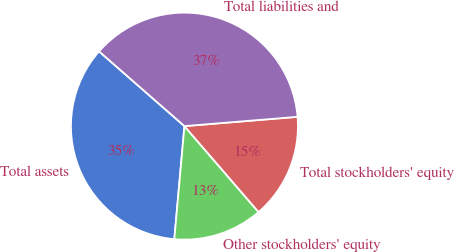<chart> <loc_0><loc_0><loc_500><loc_500><pie_chart><fcel>Total assets<fcel>Other stockholders' equity<fcel>Total stockholders' equity<fcel>Total liabilities and<nl><fcel>35.02%<fcel>12.75%<fcel>14.98%<fcel>37.25%<nl></chart> 